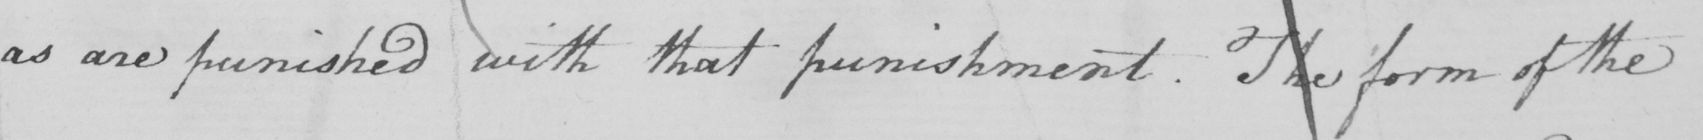Transcribe the text shown in this historical manuscript line. as are punished with that punishment . The form of the 